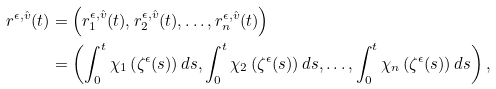Convert formula to latex. <formula><loc_0><loc_0><loc_500><loc_500>r ^ { \epsilon , \hat { v } } ( t ) & = \left ( r _ { 1 } ^ { \epsilon , \hat { v } } ( t ) , r _ { 2 } ^ { \epsilon , \hat { v } } ( t ) , \dots , r _ { n } ^ { \epsilon , \hat { v } } ( t ) \right ) \\ & = \left ( \int _ { 0 } ^ { t } \chi _ { 1 } \left ( \zeta ^ { \epsilon } ( s ) \right ) d s , \int _ { 0 } ^ { t } \chi _ { 2 } \left ( \zeta ^ { \epsilon } ( s ) \right ) d s , \dots , \int _ { 0 } ^ { t } \chi _ { n } \left ( \zeta ^ { \epsilon } ( s ) \right ) d s \right ) ,</formula> 